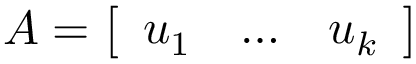Convert formula to latex. <formula><loc_0><loc_0><loc_500><loc_500>A = { \left [ \begin{array} { l l l } { u _ { 1 } } & { \dots } & { u _ { k } } \end{array} \right ] }</formula> 